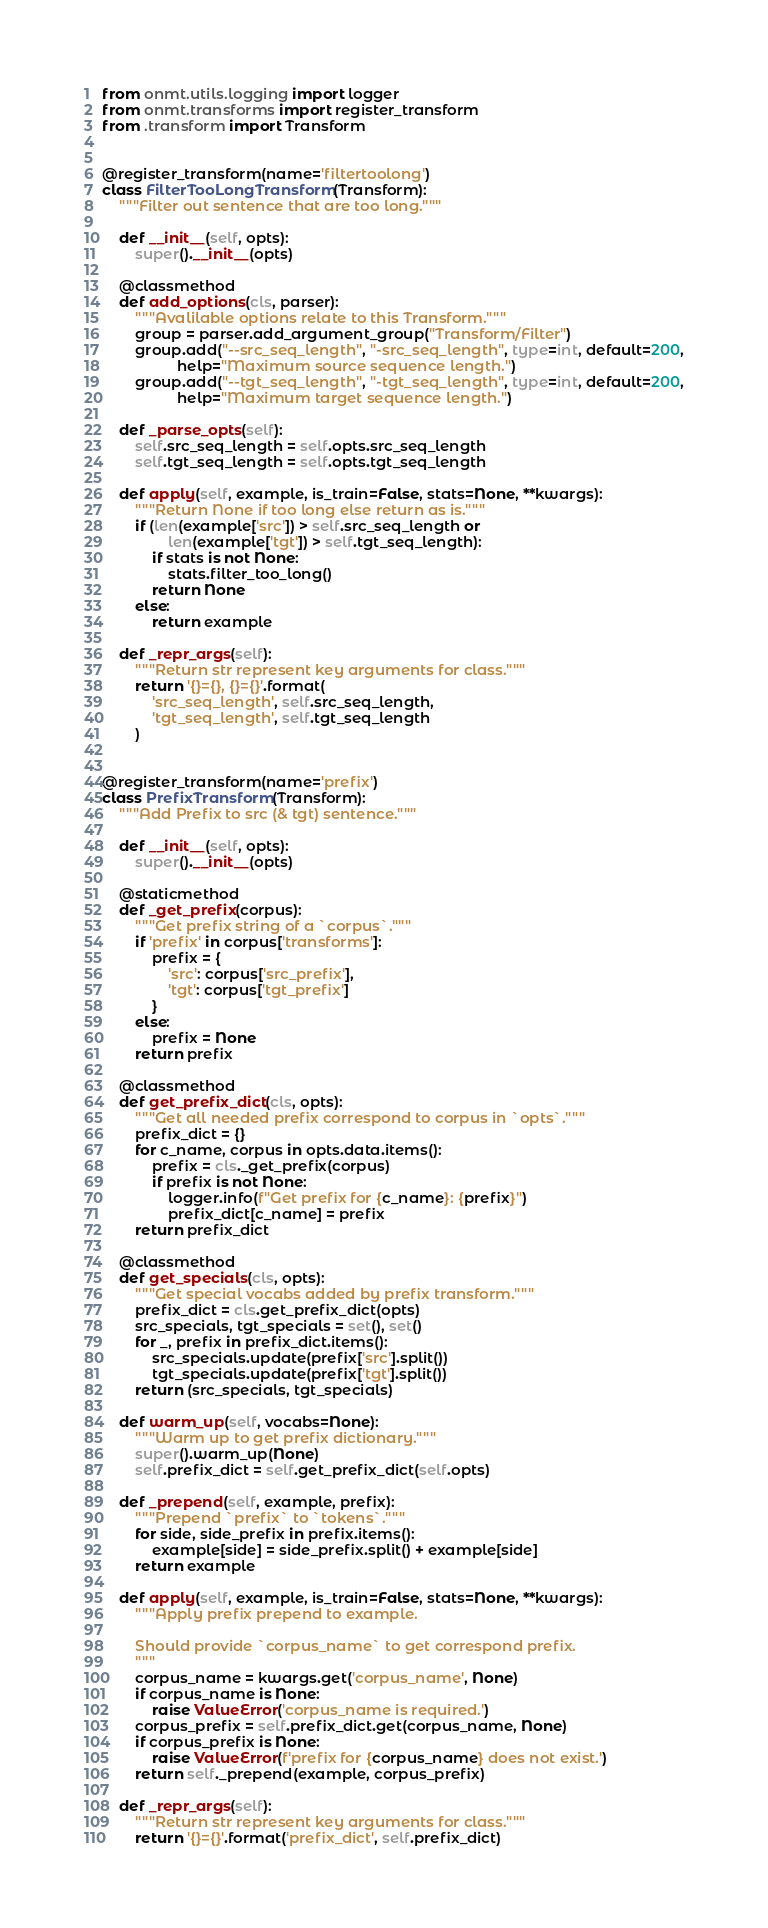Convert code to text. <code><loc_0><loc_0><loc_500><loc_500><_Python_>from onmt.utils.logging import logger
from onmt.transforms import register_transform
from .transform import Transform


@register_transform(name='filtertoolong')
class FilterTooLongTransform(Transform):
    """Filter out sentence that are too long."""

    def __init__(self, opts):
        super().__init__(opts)

    @classmethod
    def add_options(cls, parser):
        """Avalilable options relate to this Transform."""
        group = parser.add_argument_group("Transform/Filter")
        group.add("--src_seq_length", "-src_seq_length", type=int, default=200,
                  help="Maximum source sequence length.")
        group.add("--tgt_seq_length", "-tgt_seq_length", type=int, default=200,
                  help="Maximum target sequence length.")

    def _parse_opts(self):
        self.src_seq_length = self.opts.src_seq_length
        self.tgt_seq_length = self.opts.tgt_seq_length

    def apply(self, example, is_train=False, stats=None, **kwargs):
        """Return None if too long else return as is."""
        if (len(example['src']) > self.src_seq_length or
                len(example['tgt']) > self.tgt_seq_length):
            if stats is not None:
                stats.filter_too_long()
            return None
        else:
            return example

    def _repr_args(self):
        """Return str represent key arguments for class."""
        return '{}={}, {}={}'.format(
            'src_seq_length', self.src_seq_length,
            'tgt_seq_length', self.tgt_seq_length
        )


@register_transform(name='prefix')
class PrefixTransform(Transform):
    """Add Prefix to src (& tgt) sentence."""

    def __init__(self, opts):
        super().__init__(opts)

    @staticmethod
    def _get_prefix(corpus):
        """Get prefix string of a `corpus`."""
        if 'prefix' in corpus['transforms']:
            prefix = {
                'src': corpus['src_prefix'],
                'tgt': corpus['tgt_prefix']
            }
        else:
            prefix = None
        return prefix

    @classmethod
    def get_prefix_dict(cls, opts):
        """Get all needed prefix correspond to corpus in `opts`."""
        prefix_dict = {}
        for c_name, corpus in opts.data.items():
            prefix = cls._get_prefix(corpus)
            if prefix is not None:
                logger.info(f"Get prefix for {c_name}: {prefix}")
                prefix_dict[c_name] = prefix
        return prefix_dict

    @classmethod
    def get_specials(cls, opts):
        """Get special vocabs added by prefix transform."""
        prefix_dict = cls.get_prefix_dict(opts)
        src_specials, tgt_specials = set(), set()
        for _, prefix in prefix_dict.items():
            src_specials.update(prefix['src'].split())
            tgt_specials.update(prefix['tgt'].split())
        return (src_specials, tgt_specials)

    def warm_up(self, vocabs=None):
        """Warm up to get prefix dictionary."""
        super().warm_up(None)
        self.prefix_dict = self.get_prefix_dict(self.opts)

    def _prepend(self, example, prefix):
        """Prepend `prefix` to `tokens`."""
        for side, side_prefix in prefix.items():
            example[side] = side_prefix.split() + example[side]
        return example

    def apply(self, example, is_train=False, stats=None, **kwargs):
        """Apply prefix prepend to example.

        Should provide `corpus_name` to get correspond prefix.
        """
        corpus_name = kwargs.get('corpus_name', None)
        if corpus_name is None:
            raise ValueError('corpus_name is required.')
        corpus_prefix = self.prefix_dict.get(corpus_name, None)
        if corpus_prefix is None:
            raise ValueError(f'prefix for {corpus_name} does not exist.')
        return self._prepend(example, corpus_prefix)

    def _repr_args(self):
        """Return str represent key arguments for class."""
        return '{}={}'.format('prefix_dict', self.prefix_dict)
</code> 